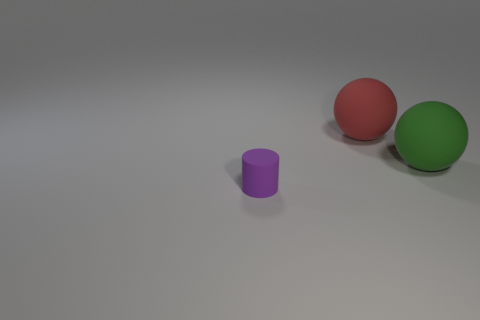Add 1 rubber cylinders. How many objects exist? 4 Subtract all cylinders. How many objects are left? 2 Subtract all big green rubber things. Subtract all tiny yellow spheres. How many objects are left? 2 Add 2 big green balls. How many big green balls are left? 3 Add 1 tiny things. How many tiny things exist? 2 Subtract 0 brown cylinders. How many objects are left? 3 